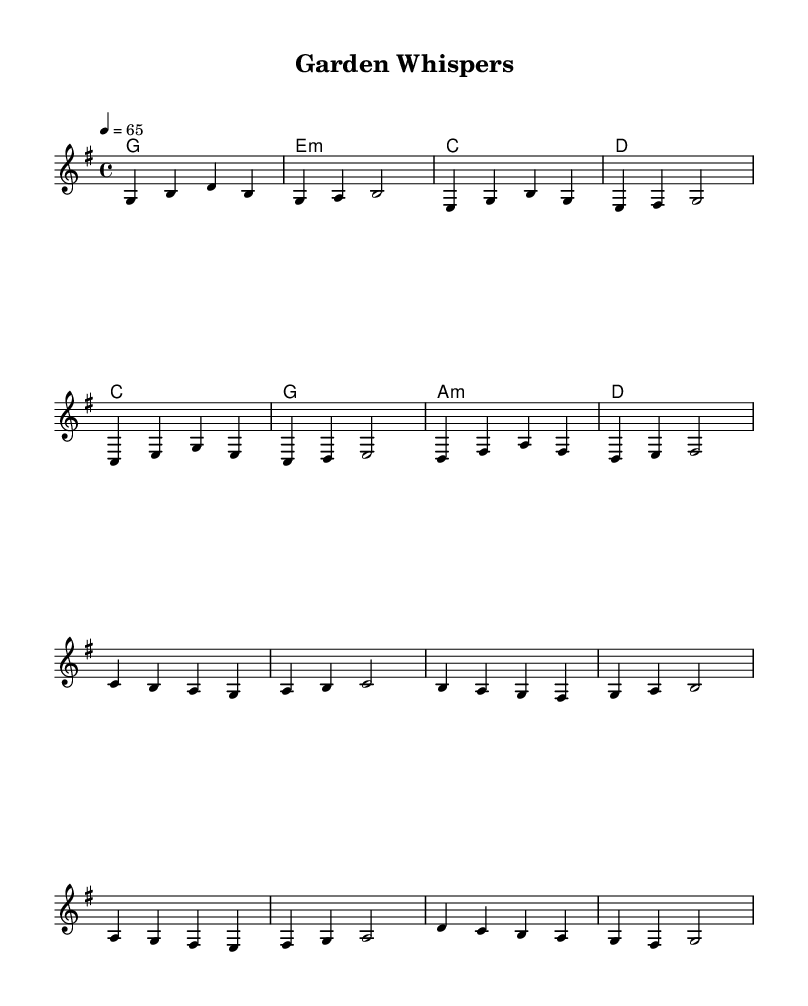what is the key signature of this music? The key signature is G major, which has one sharp. This can be identified by checking the key signature at the beginning of the sheet music, which indicates G major.
Answer: G major what is the time signature of this music? The time signature is 4/4, which can be recognized as there are four beats in each measure, indicated at the beginning of the sheet music.
Answer: 4/4 what is the tempo marking of this music? The tempo marking is 65 beats per minute, which is shown at the beginning with the indication "4 = 65". This tells the performers to play at a moderate pace.
Answer: 65 how many measures are in the verse section? The verse section consists of 8 measures, which can be counted from the beginning of the verse until it transitions to the chorus. This is visible by looking at the measure lines and counting them.
Answer: 8 what is the harmony used in the chorus? The harmony in the chorus involves the chords C, G, A minor, and D, as specified in the chord section beneath the melody. Each chord corresponds to the respective measures in the chorus.
Answer: C, G, A minor, D which musical genre does this piece belong to? This piece belongs to the country rock genre, identifiable through its mellow ballad style and thematic focus on tranquility, aligning with the characteristics of a country rock ballad.
Answer: Country rock 